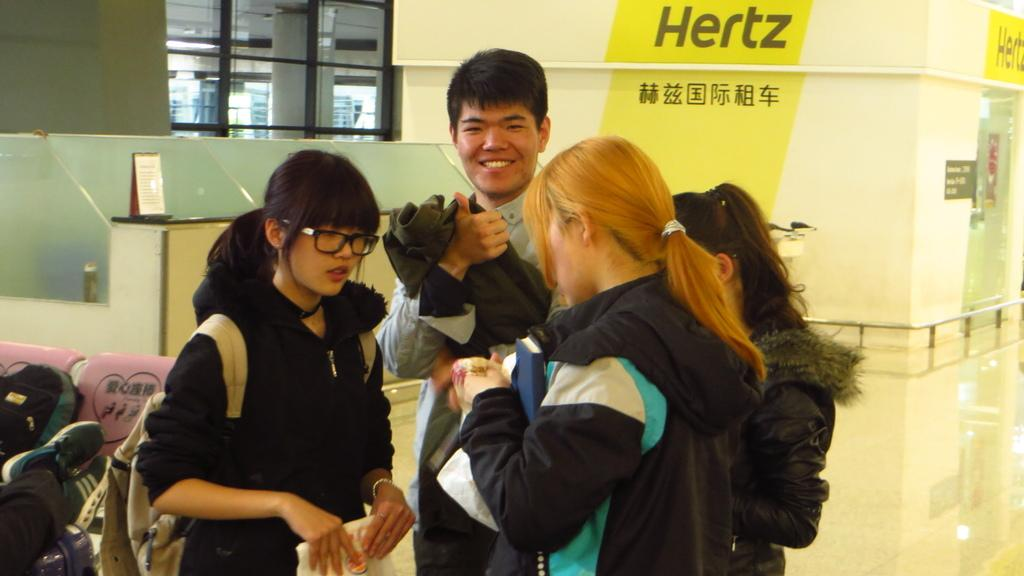How many people are in the image? There are four persons standing in the image. Can you describe the facial expression of one of the persons? One person is smiling. What can be seen in the background of the image? There is a board, a pair of shoes, a bag, and chairs visible in the background of the image. What type of rock is being used to patch the hole in the image? There is no hole or rock present in the image. 